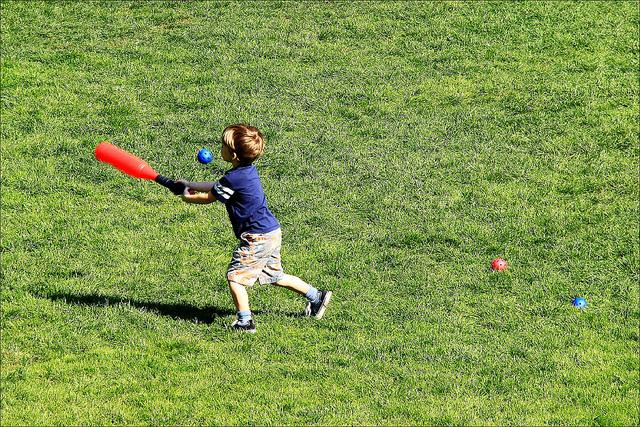Why does the boy have his arms out? Please explain your reasoning. swing. There is a boy with a bat trying to hit a ball in the air. 